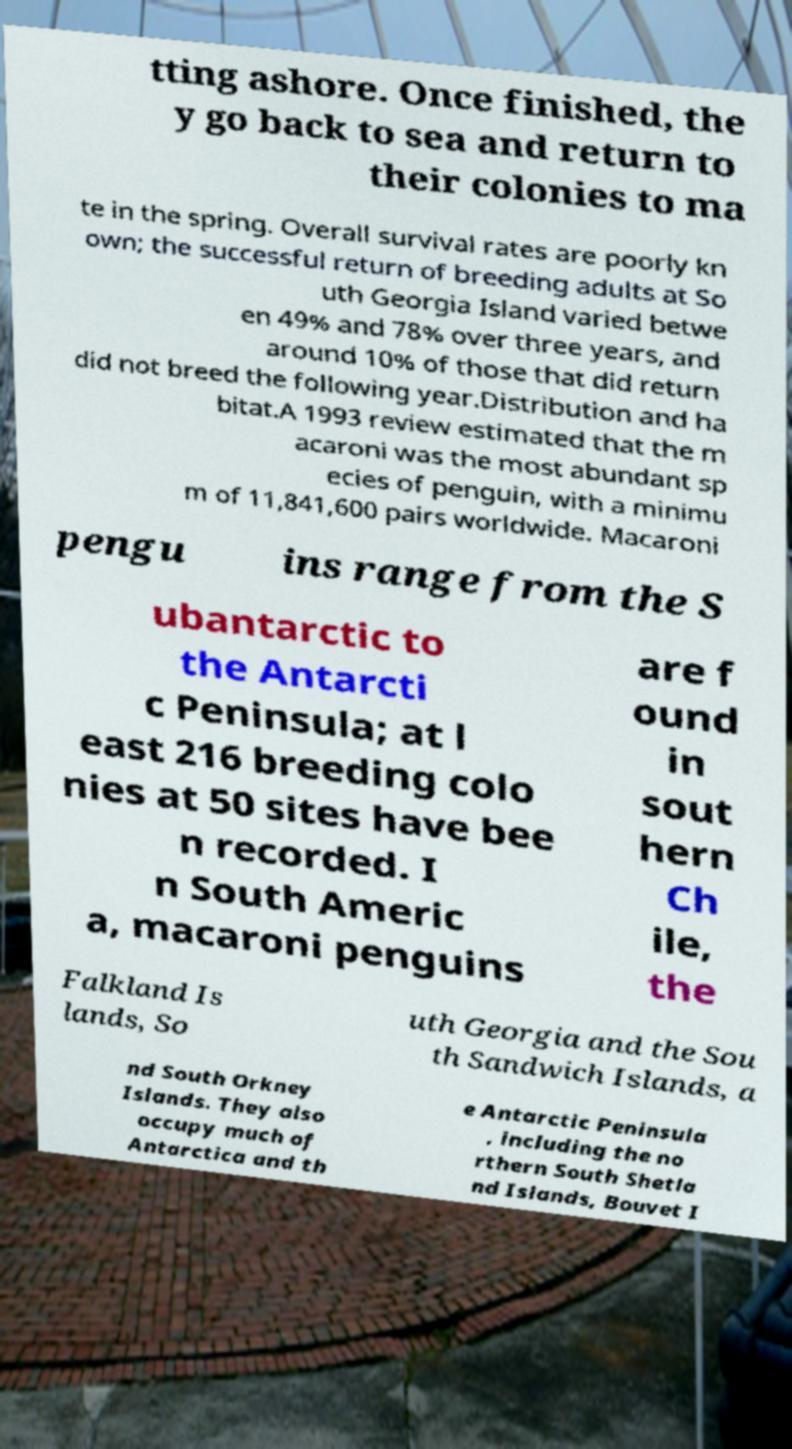Please read and relay the text visible in this image. What does it say? tting ashore. Once finished, the y go back to sea and return to their colonies to ma te in the spring. Overall survival rates are poorly kn own; the successful return of breeding adults at So uth Georgia Island varied betwe en 49% and 78% over three years, and around 10% of those that did return did not breed the following year.Distribution and ha bitat.A 1993 review estimated that the m acaroni was the most abundant sp ecies of penguin, with a minimu m of 11,841,600 pairs worldwide. Macaroni pengu ins range from the S ubantarctic to the Antarcti c Peninsula; at l east 216 breeding colo nies at 50 sites have bee n recorded. I n South Americ a, macaroni penguins are f ound in sout hern Ch ile, the Falkland Is lands, So uth Georgia and the Sou th Sandwich Islands, a nd South Orkney Islands. They also occupy much of Antarctica and th e Antarctic Peninsula , including the no rthern South Shetla nd Islands, Bouvet I 